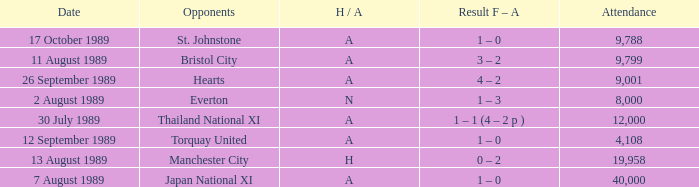When did the game take place between manchester united and bristol city, with manchester united having an h/a of a? 11 August 1989. 